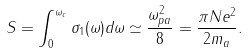Convert formula to latex. <formula><loc_0><loc_0><loc_500><loc_500>S = \int _ { 0 } ^ { \omega _ { c } } \sigma _ { 1 } ( \omega ) d \omega \simeq \frac { \omega _ { p a } ^ { 2 } } { 8 } = \frac { \pi N e ^ { 2 } } { 2 m _ { a } } .</formula> 